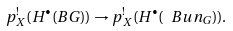<formula> <loc_0><loc_0><loc_500><loc_500>p _ { X } ^ { ! } ( H ^ { \bullet } ( B G ) ) \to p _ { X } ^ { ! } ( H ^ { \bullet } ( \ B u n _ { G } ) ) .</formula> 